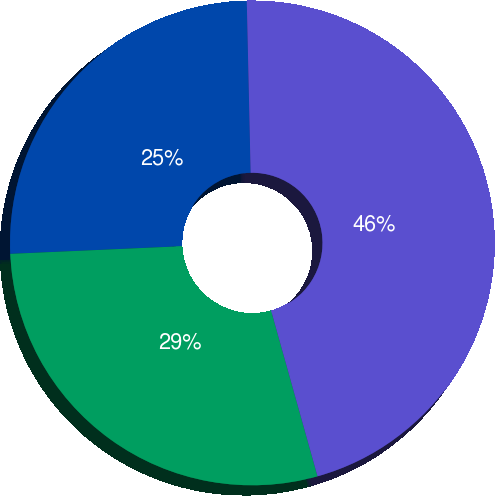<chart> <loc_0><loc_0><loc_500><loc_500><pie_chart><fcel>Liability<fcel>Deferred tax<fcel>Accumulated OCI<nl><fcel>25.35%<fcel>28.64%<fcel>46.01%<nl></chart> 